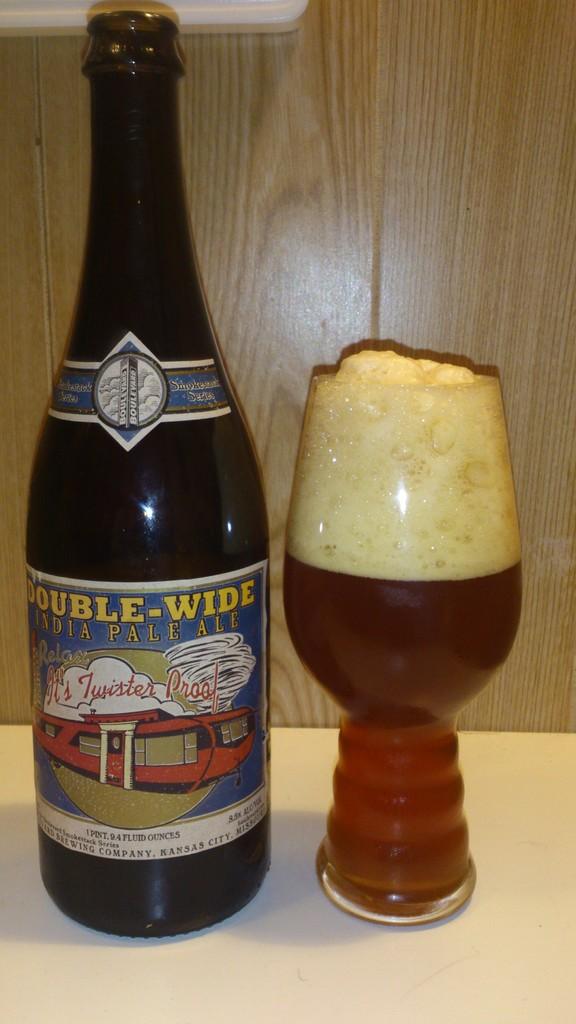What is the type of beer on the left?
Your answer should be compact. India pale ale. Where was the ale made?
Make the answer very short. India. 